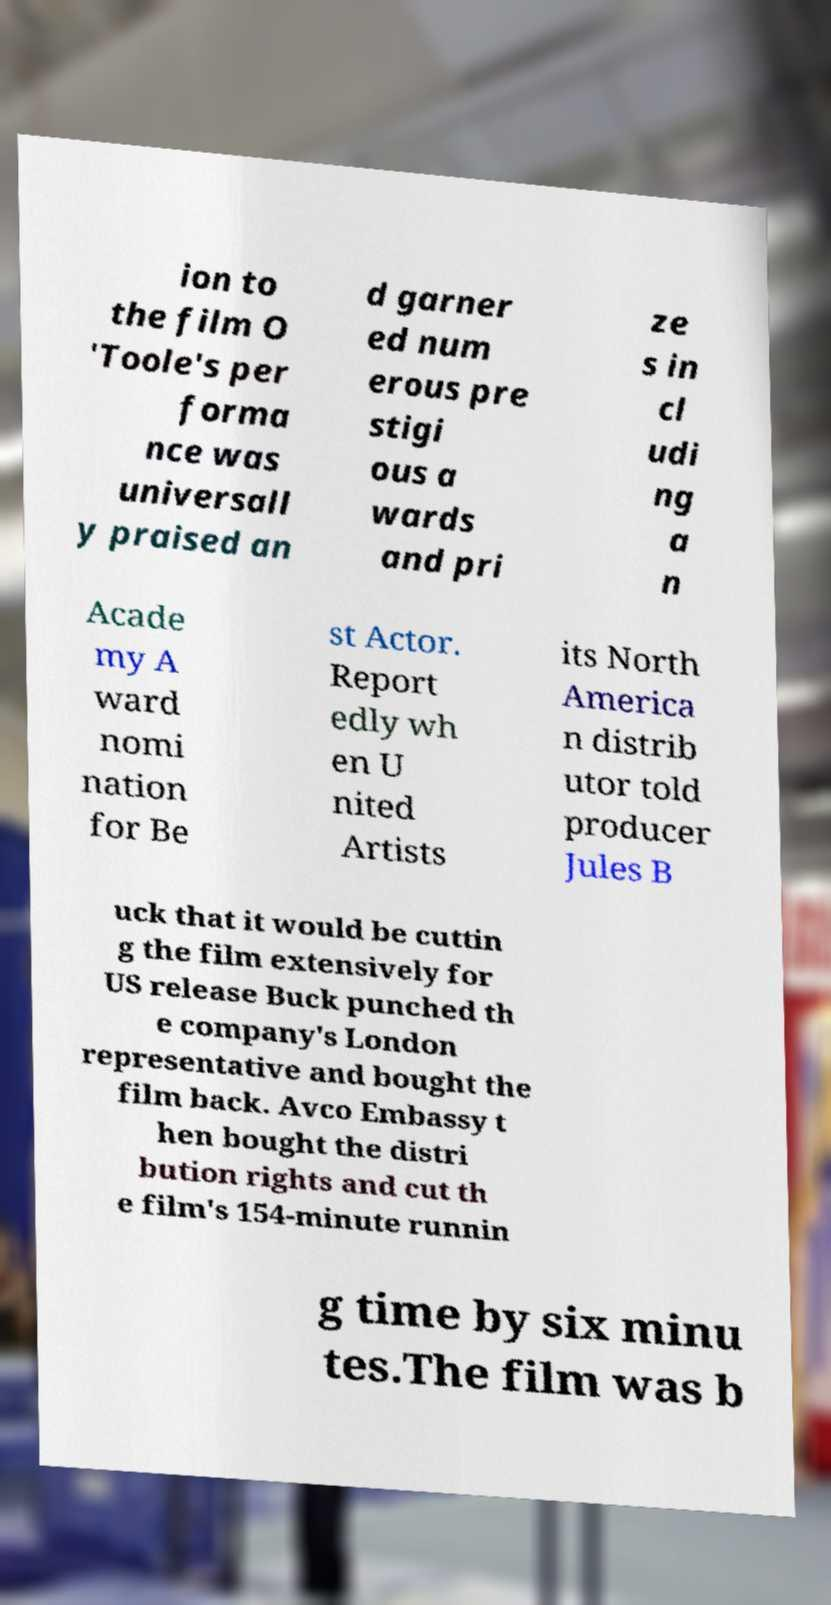I need the written content from this picture converted into text. Can you do that? ion to the film O 'Toole's per forma nce was universall y praised an d garner ed num erous pre stigi ous a wards and pri ze s in cl udi ng a n Acade my A ward nomi nation for Be st Actor. Report edly wh en U nited Artists its North America n distrib utor told producer Jules B uck that it would be cuttin g the film extensively for US release Buck punched th e company's London representative and bought the film back. Avco Embassy t hen bought the distri bution rights and cut th e film's 154-minute runnin g time by six minu tes.The film was b 